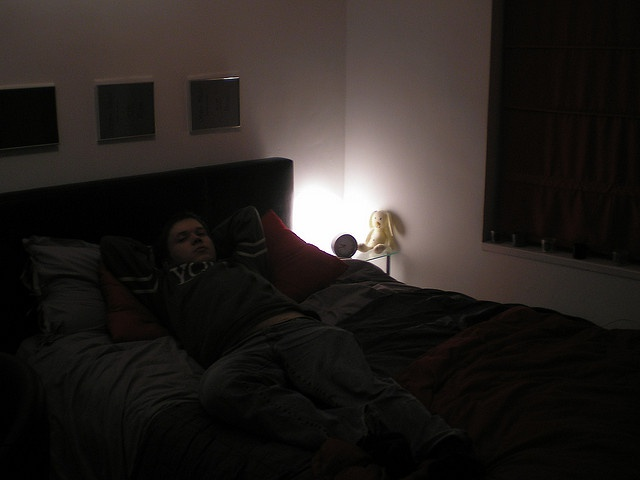Describe the objects in this image and their specific colors. I can see bed in black, gray, maroon, and white tones, people in black tones, teddy bear in black, gray, and beige tones, and clock in black tones in this image. 